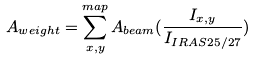<formula> <loc_0><loc_0><loc_500><loc_500>A _ { w e i g h t } = \sum _ { x , y } ^ { m a p } A _ { b e a m } ( \frac { I _ { x , y } } { I _ { I R A S 2 5 / 2 7 } } )</formula> 